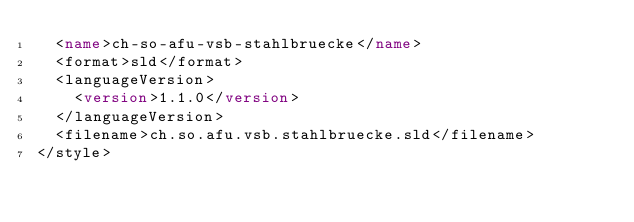<code> <loc_0><loc_0><loc_500><loc_500><_XML_>  <name>ch-so-afu-vsb-stahlbruecke</name>
  <format>sld</format>
  <languageVersion>
    <version>1.1.0</version>
  </languageVersion>
  <filename>ch.so.afu.vsb.stahlbruecke.sld</filename>
</style></code> 